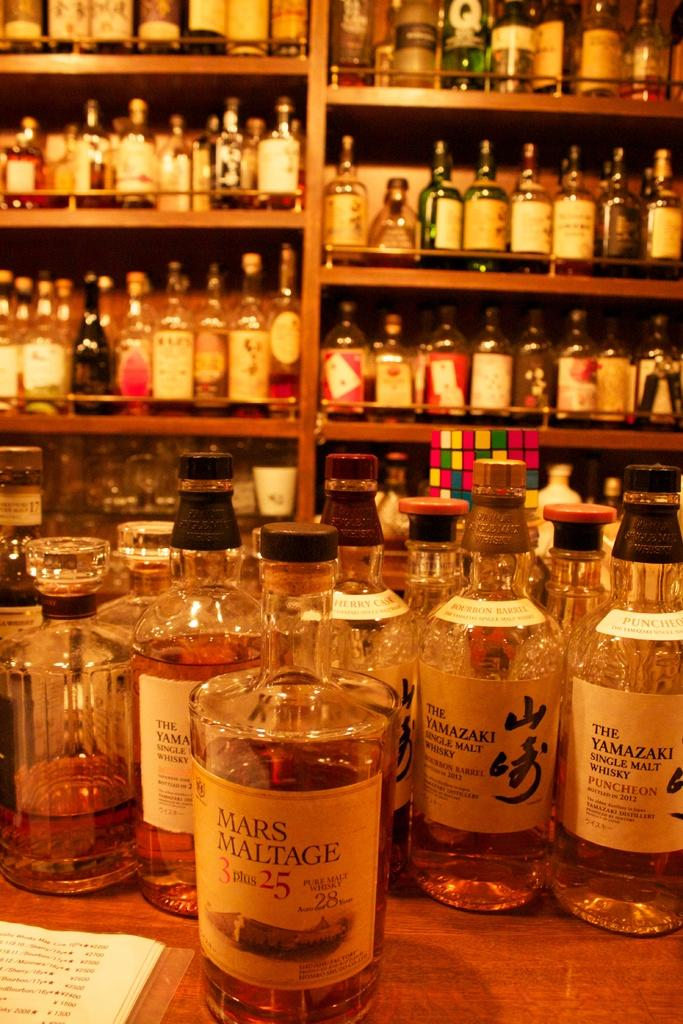<image>
Share a concise interpretation of the image provided. A glass bottle of Mars Maltage featured in front of several other bottles of whisky. 